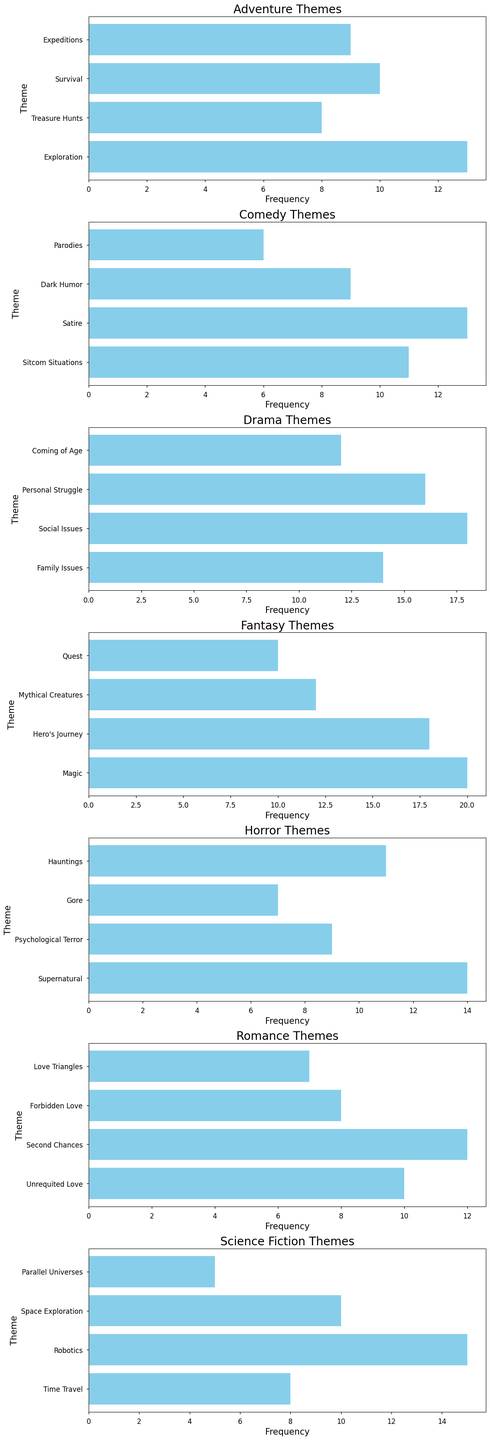Which genre has the highest frequency for any single theme? The genre with the highest frequency for any single theme can be found by looking at the bar with the greatest length among all genres. The longest bar belongs to the "Magic" theme in the Fantasy genre with a frequency of 20.
Answer: Fantasy Which theme within the Horror genre appears most frequently? Within the Horror genre, we compare the lengths of the bars for each theme. "Supernatural" has the longest bar, indicating the highest frequency of 14.
Answer: Supernatural What is the total frequency of all themes in the Science Fiction genre? To find the total frequency of all themes in the Science Fiction genre, sum the frequencies of each theme: Time Travel (8), Robotics (15), Space Exploration (10), Parallel Universes (5). So, 8 + 15 + 10 + 5 = 38.
Answer: 38 How does the frequency of "Hero's Journey" in the Fantasy genre compare to the "Personal Struggle" theme in the Drama genre? Compare the lengths of the bars for "Hero's Journey" in Fantasy and "Personal Struggle" in Drama. "Hero's Journey" has a frequency of 18, while "Personal Struggle" has a frequency of 16. 18 - 16 = 2, so "Hero's Journey" appears 2 times more frequently.
Answer: 2 more Among themes in the Romance genre, which one has the lowest frequency, and what is its frequency? The lowest frequency is represented by the shortest bar in the Romance genre. The shortest bar is "Love Triangles" with a frequency of 7.
Answer: Love Triangles with a frequency of 7 What is the average frequency of themes in the Comedy genre? To find the average, sum the frequencies of all themes in Comedy: Sitcom Situations (11), Satire (13), Dark Humor (9), Parodies (6). Then divide by the number of themes: (11 + 13 + 9 + 6) / 4 = 39 / 4 = 9.75.
Answer: 9.75 Is the frequency of "Magic" in the Fantasy genre greater than the combined frequency of all Horror themes? First, find the frequencies for the Horror themes: Supernatural (14), Psychological Terror (9), Gore (7), Hauntings (11). Sum them: 14 + 9 + 7 + 11 = 41. Frequency of "Magic" in Fantasy is 20. 20 is not greater than 41.
Answer: No What is the difference in frequency between "Space Exploration" in Science Fiction and "Quest" in the Fantasy genre? The frequency of "Space Exploration" is 10, and the frequency of "Quest" is 10. The difference is 10 - 10 = 0.
Answer: 0 What is the median frequency of the Adventure genre themes? List the frequencies of Adventure themes: Exploration (13), Treasure Hunts (8), Survival (10), Expeditions (9). Order them: 8, 9, 10, 13. The median is the average of the two middle numbers (9 + 10) / 2 = 9.5.
Answer: 9.5 